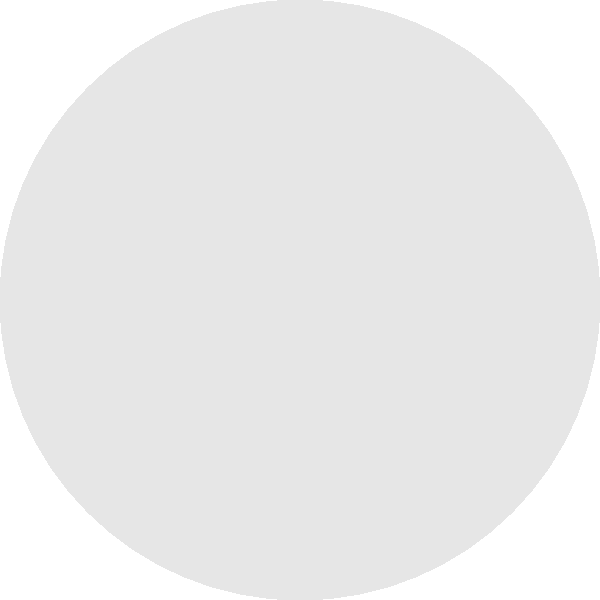Based on the diagram of the human body and the potential drug delivery routes (A, B, and C), which route would be most suitable for a new hepatoprotective drug that needs to reach the liver quickly and in high concentrations? To determine the most suitable drug delivery route for a hepatoprotective drug targeting the liver, we need to consider the following factors:

1. Direct access to the liver: The liver is the target organ for the hepatoprotective drug.
2. Speed of delivery: The drug needs to reach the liver quickly.
3. Concentration: High concentrations of the drug should reach the liver.

Analyzing the routes:

A. This route leads directly to the liver. It represents the most direct path, which would allow for:
   - Fastest delivery to the target organ
   - Minimal metabolism or dilution before reaching the liver
   - Highest concentration of the drug in the liver

B. This route leads to the stomach. While it's a common route for oral medications, it has several disadvantages for this specific case:
   - Longer path to reach the liver
   - Potential degradation of the drug in the acidic stomach environment
   - Lower concentration reaching the liver due to first-pass metabolism

C. This route leads to the intestine. Similar to route B, it has limitations:
   - Even longer path to reach the liver
   - Potential degradation or incomplete absorption in the intestine
   - Lower concentration reaching the liver due to first-pass metabolism

Given these considerations, route A is the most suitable for delivering a hepatoprotective drug quickly and in high concentrations to the liver.
Answer: Route A 